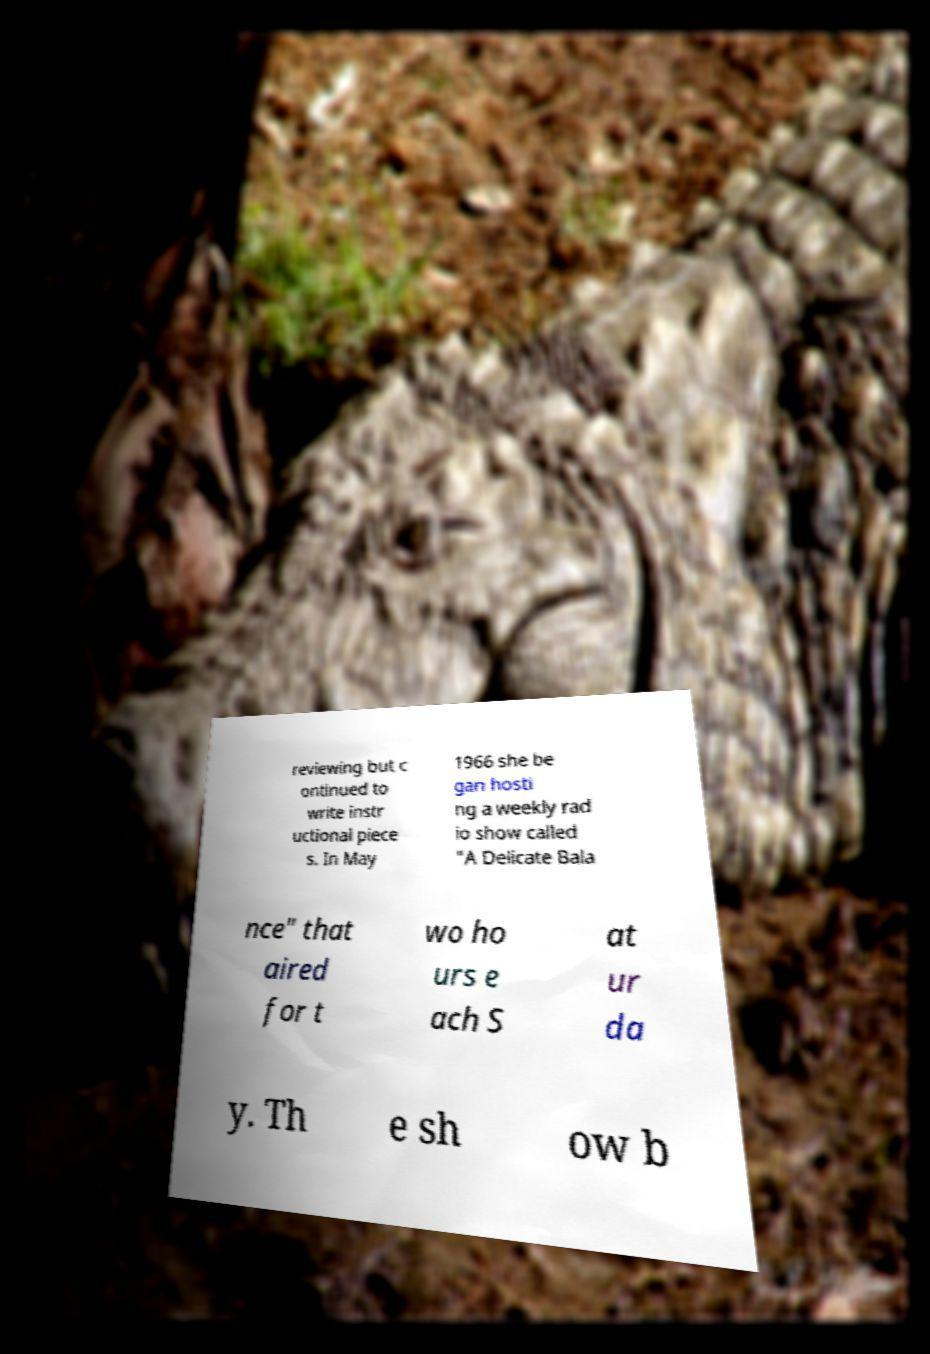What messages or text are displayed in this image? I need them in a readable, typed format. reviewing but c ontinued to write instr uctional piece s. In May 1966 she be gan hosti ng a weekly rad io show called "A Delicate Bala nce" that aired for t wo ho urs e ach S at ur da y. Th e sh ow b 